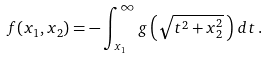Convert formula to latex. <formula><loc_0><loc_0><loc_500><loc_500>f ( x _ { 1 } , x _ { 2 } ) = - \int _ { x _ { 1 } } ^ { \infty } g \left ( \sqrt { t ^ { 2 } + x _ { 2 } ^ { 2 } } \, \right ) \, d t \, .</formula> 